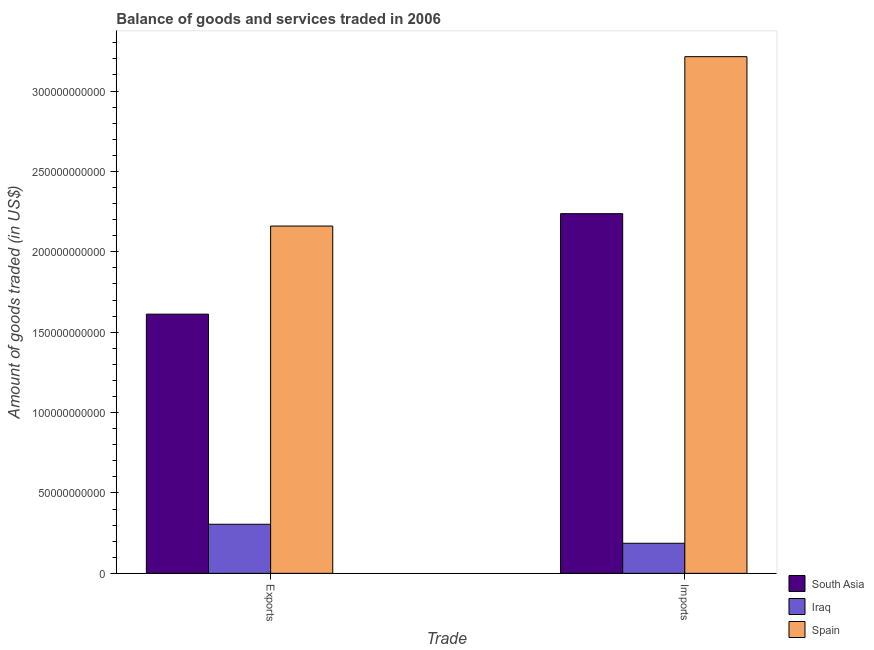How many different coloured bars are there?
Offer a terse response. 3. How many groups of bars are there?
Your answer should be very brief. 2. How many bars are there on the 1st tick from the right?
Provide a short and direct response. 3. What is the label of the 1st group of bars from the left?
Give a very brief answer. Exports. What is the amount of goods imported in South Asia?
Give a very brief answer. 2.24e+11. Across all countries, what is the maximum amount of goods exported?
Offer a very short reply. 2.16e+11. Across all countries, what is the minimum amount of goods exported?
Your response must be concise. 3.05e+1. In which country was the amount of goods exported minimum?
Provide a succinct answer. Iraq. What is the total amount of goods imported in the graph?
Keep it short and to the point. 5.64e+11. What is the difference between the amount of goods exported in Spain and that in South Asia?
Your response must be concise. 5.48e+1. What is the difference between the amount of goods exported in South Asia and the amount of goods imported in Spain?
Your response must be concise. -1.60e+11. What is the average amount of goods exported per country?
Offer a very short reply. 1.36e+11. What is the difference between the amount of goods exported and amount of goods imported in Iraq?
Give a very brief answer. 1.18e+1. In how many countries, is the amount of goods imported greater than 160000000000 US$?
Keep it short and to the point. 2. What is the ratio of the amount of goods imported in South Asia to that in Iraq?
Provide a succinct answer. 11.96. In how many countries, is the amount of goods exported greater than the average amount of goods exported taken over all countries?
Your answer should be very brief. 2. What does the 2nd bar from the left in Imports represents?
Offer a very short reply. Iraq. What does the 2nd bar from the right in Imports represents?
Give a very brief answer. Iraq. How many bars are there?
Offer a very short reply. 6. What is the difference between two consecutive major ticks on the Y-axis?
Offer a terse response. 5.00e+1. Does the graph contain any zero values?
Your response must be concise. No. Where does the legend appear in the graph?
Offer a terse response. Bottom right. How many legend labels are there?
Provide a short and direct response. 3. What is the title of the graph?
Provide a short and direct response. Balance of goods and services traded in 2006. What is the label or title of the X-axis?
Give a very brief answer. Trade. What is the label or title of the Y-axis?
Provide a succinct answer. Amount of goods traded (in US$). What is the Amount of goods traded (in US$) of South Asia in Exports?
Make the answer very short. 1.61e+11. What is the Amount of goods traded (in US$) in Iraq in Exports?
Provide a succinct answer. 3.05e+1. What is the Amount of goods traded (in US$) of Spain in Exports?
Ensure brevity in your answer.  2.16e+11. What is the Amount of goods traded (in US$) of South Asia in Imports?
Your answer should be very brief. 2.24e+11. What is the Amount of goods traded (in US$) in Iraq in Imports?
Your answer should be compact. 1.87e+1. What is the Amount of goods traded (in US$) of Spain in Imports?
Offer a very short reply. 3.21e+11. Across all Trade, what is the maximum Amount of goods traded (in US$) in South Asia?
Make the answer very short. 2.24e+11. Across all Trade, what is the maximum Amount of goods traded (in US$) of Iraq?
Your answer should be very brief. 3.05e+1. Across all Trade, what is the maximum Amount of goods traded (in US$) in Spain?
Your answer should be very brief. 3.21e+11. Across all Trade, what is the minimum Amount of goods traded (in US$) of South Asia?
Provide a succinct answer. 1.61e+11. Across all Trade, what is the minimum Amount of goods traded (in US$) of Iraq?
Your answer should be compact. 1.87e+1. Across all Trade, what is the minimum Amount of goods traded (in US$) of Spain?
Keep it short and to the point. 2.16e+11. What is the total Amount of goods traded (in US$) of South Asia in the graph?
Give a very brief answer. 3.85e+11. What is the total Amount of goods traded (in US$) of Iraq in the graph?
Give a very brief answer. 4.92e+1. What is the total Amount of goods traded (in US$) of Spain in the graph?
Offer a very short reply. 5.37e+11. What is the difference between the Amount of goods traded (in US$) in South Asia in Exports and that in Imports?
Make the answer very short. -6.25e+1. What is the difference between the Amount of goods traded (in US$) in Iraq in Exports and that in Imports?
Offer a very short reply. 1.18e+1. What is the difference between the Amount of goods traded (in US$) in Spain in Exports and that in Imports?
Your response must be concise. -1.05e+11. What is the difference between the Amount of goods traded (in US$) in South Asia in Exports and the Amount of goods traded (in US$) in Iraq in Imports?
Offer a terse response. 1.43e+11. What is the difference between the Amount of goods traded (in US$) in South Asia in Exports and the Amount of goods traded (in US$) in Spain in Imports?
Offer a terse response. -1.60e+11. What is the difference between the Amount of goods traded (in US$) in Iraq in Exports and the Amount of goods traded (in US$) in Spain in Imports?
Keep it short and to the point. -2.91e+11. What is the average Amount of goods traded (in US$) of South Asia per Trade?
Offer a terse response. 1.92e+11. What is the average Amount of goods traded (in US$) in Iraq per Trade?
Ensure brevity in your answer.  2.46e+1. What is the average Amount of goods traded (in US$) in Spain per Trade?
Your response must be concise. 2.69e+11. What is the difference between the Amount of goods traded (in US$) of South Asia and Amount of goods traded (in US$) of Iraq in Exports?
Give a very brief answer. 1.31e+11. What is the difference between the Amount of goods traded (in US$) in South Asia and Amount of goods traded (in US$) in Spain in Exports?
Offer a very short reply. -5.48e+1. What is the difference between the Amount of goods traded (in US$) of Iraq and Amount of goods traded (in US$) of Spain in Exports?
Your response must be concise. -1.85e+11. What is the difference between the Amount of goods traded (in US$) in South Asia and Amount of goods traded (in US$) in Iraq in Imports?
Your response must be concise. 2.05e+11. What is the difference between the Amount of goods traded (in US$) in South Asia and Amount of goods traded (in US$) in Spain in Imports?
Give a very brief answer. -9.77e+1. What is the difference between the Amount of goods traded (in US$) in Iraq and Amount of goods traded (in US$) in Spain in Imports?
Provide a succinct answer. -3.03e+11. What is the ratio of the Amount of goods traded (in US$) of South Asia in Exports to that in Imports?
Offer a very short reply. 0.72. What is the ratio of the Amount of goods traded (in US$) in Iraq in Exports to that in Imports?
Provide a succinct answer. 1.63. What is the ratio of the Amount of goods traded (in US$) of Spain in Exports to that in Imports?
Your answer should be compact. 0.67. What is the difference between the highest and the second highest Amount of goods traded (in US$) of South Asia?
Your response must be concise. 6.25e+1. What is the difference between the highest and the second highest Amount of goods traded (in US$) of Iraq?
Your answer should be very brief. 1.18e+1. What is the difference between the highest and the second highest Amount of goods traded (in US$) of Spain?
Your response must be concise. 1.05e+11. What is the difference between the highest and the lowest Amount of goods traded (in US$) in South Asia?
Ensure brevity in your answer.  6.25e+1. What is the difference between the highest and the lowest Amount of goods traded (in US$) of Iraq?
Your answer should be very brief. 1.18e+1. What is the difference between the highest and the lowest Amount of goods traded (in US$) in Spain?
Make the answer very short. 1.05e+11. 